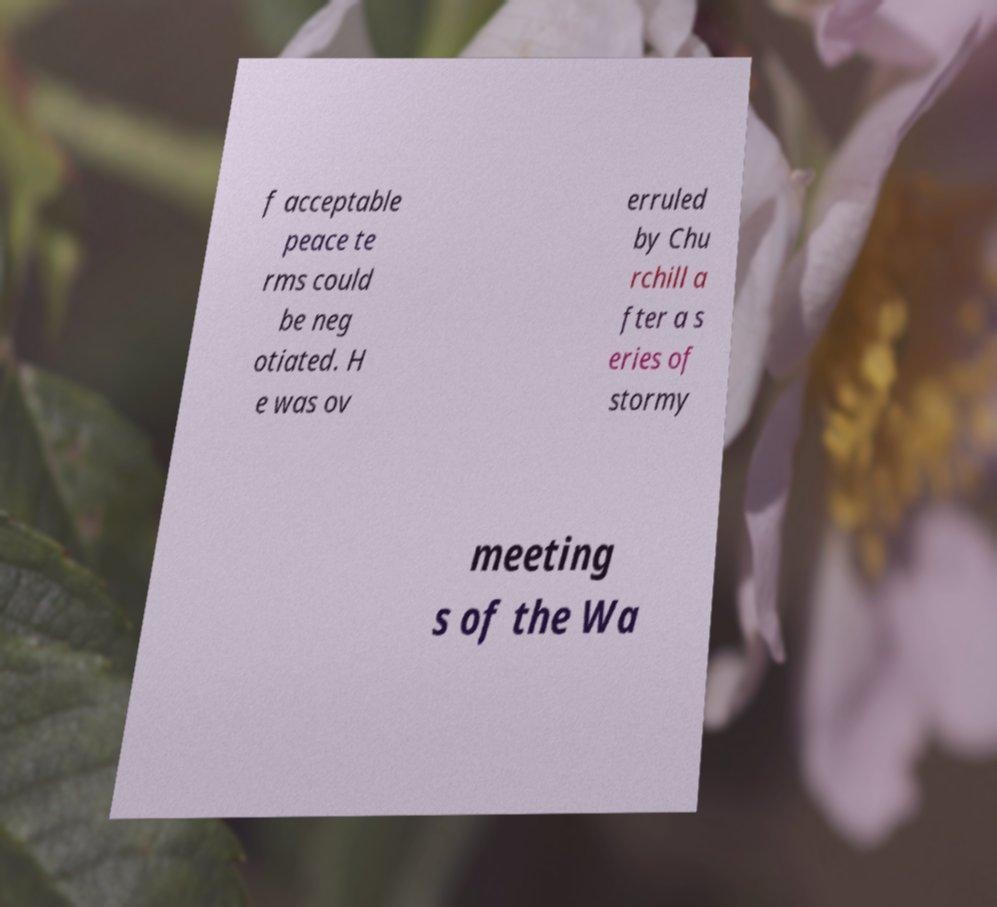I need the written content from this picture converted into text. Can you do that? f acceptable peace te rms could be neg otiated. H e was ov erruled by Chu rchill a fter a s eries of stormy meeting s of the Wa 